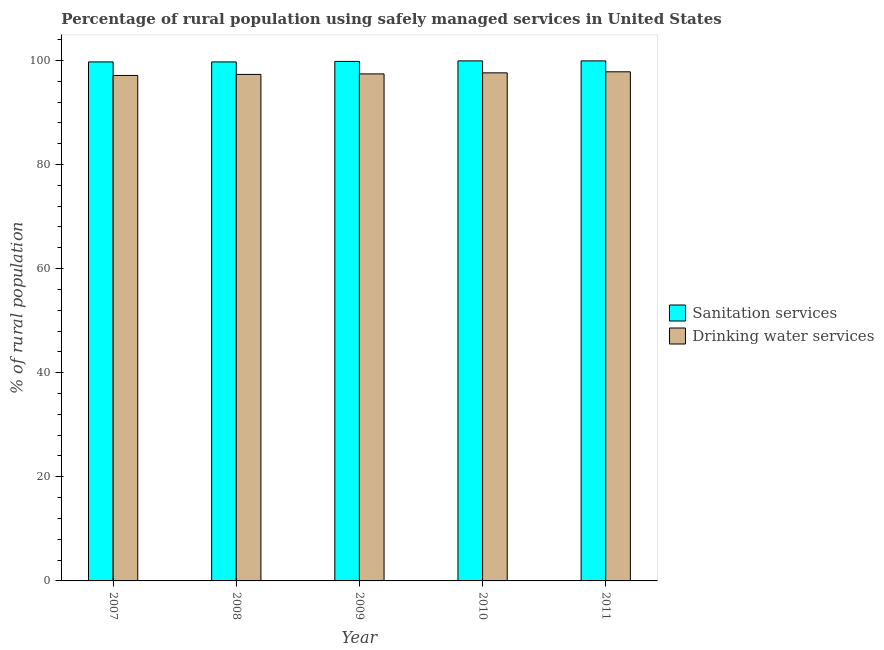How many groups of bars are there?
Make the answer very short. 5. Are the number of bars per tick equal to the number of legend labels?
Provide a succinct answer. Yes. How many bars are there on the 2nd tick from the left?
Make the answer very short. 2. How many bars are there on the 5th tick from the right?
Your answer should be compact. 2. What is the percentage of rural population who used sanitation services in 2011?
Make the answer very short. 99.9. Across all years, what is the maximum percentage of rural population who used drinking water services?
Offer a terse response. 97.8. Across all years, what is the minimum percentage of rural population who used drinking water services?
Your answer should be compact. 97.1. In which year was the percentage of rural population who used sanitation services maximum?
Offer a terse response. 2010. In which year was the percentage of rural population who used sanitation services minimum?
Your answer should be compact. 2007. What is the total percentage of rural population who used sanitation services in the graph?
Your response must be concise. 499. What is the difference between the percentage of rural population who used sanitation services in 2007 and that in 2008?
Keep it short and to the point. 0. What is the difference between the percentage of rural population who used sanitation services in 2008 and the percentage of rural population who used drinking water services in 2009?
Provide a short and direct response. -0.1. What is the average percentage of rural population who used drinking water services per year?
Offer a very short reply. 97.44. In the year 2011, what is the difference between the percentage of rural population who used drinking water services and percentage of rural population who used sanitation services?
Offer a very short reply. 0. What is the ratio of the percentage of rural population who used drinking water services in 2009 to that in 2010?
Your answer should be compact. 1. Is the percentage of rural population who used drinking water services in 2007 less than that in 2009?
Keep it short and to the point. Yes. Is the difference between the percentage of rural population who used drinking water services in 2007 and 2010 greater than the difference between the percentage of rural population who used sanitation services in 2007 and 2010?
Offer a terse response. No. What is the difference between the highest and the second highest percentage of rural population who used drinking water services?
Give a very brief answer. 0.2. What is the difference between the highest and the lowest percentage of rural population who used drinking water services?
Give a very brief answer. 0.7. What does the 2nd bar from the left in 2007 represents?
Provide a short and direct response. Drinking water services. What does the 2nd bar from the right in 2011 represents?
Your answer should be compact. Sanitation services. Are all the bars in the graph horizontal?
Your response must be concise. No. What is the difference between two consecutive major ticks on the Y-axis?
Your answer should be very brief. 20. Does the graph contain grids?
Offer a terse response. No. What is the title of the graph?
Give a very brief answer. Percentage of rural population using safely managed services in United States. What is the label or title of the X-axis?
Make the answer very short. Year. What is the label or title of the Y-axis?
Give a very brief answer. % of rural population. What is the % of rural population in Sanitation services in 2007?
Offer a very short reply. 99.7. What is the % of rural population in Drinking water services in 2007?
Offer a very short reply. 97.1. What is the % of rural population of Sanitation services in 2008?
Make the answer very short. 99.7. What is the % of rural population in Drinking water services in 2008?
Your answer should be compact. 97.3. What is the % of rural population of Sanitation services in 2009?
Keep it short and to the point. 99.8. What is the % of rural population of Drinking water services in 2009?
Provide a succinct answer. 97.4. What is the % of rural population in Sanitation services in 2010?
Provide a short and direct response. 99.9. What is the % of rural population of Drinking water services in 2010?
Keep it short and to the point. 97.6. What is the % of rural population of Sanitation services in 2011?
Keep it short and to the point. 99.9. What is the % of rural population in Drinking water services in 2011?
Your answer should be very brief. 97.8. Across all years, what is the maximum % of rural population in Sanitation services?
Your answer should be compact. 99.9. Across all years, what is the maximum % of rural population of Drinking water services?
Your response must be concise. 97.8. Across all years, what is the minimum % of rural population in Sanitation services?
Make the answer very short. 99.7. Across all years, what is the minimum % of rural population in Drinking water services?
Your answer should be very brief. 97.1. What is the total % of rural population of Sanitation services in the graph?
Offer a very short reply. 499. What is the total % of rural population in Drinking water services in the graph?
Offer a very short reply. 487.2. What is the difference between the % of rural population in Drinking water services in 2007 and that in 2008?
Ensure brevity in your answer.  -0.2. What is the difference between the % of rural population of Sanitation services in 2007 and that in 2009?
Provide a succinct answer. -0.1. What is the difference between the % of rural population in Drinking water services in 2007 and that in 2009?
Your answer should be very brief. -0.3. What is the difference between the % of rural population in Drinking water services in 2007 and that in 2011?
Provide a succinct answer. -0.7. What is the difference between the % of rural population in Drinking water services in 2008 and that in 2009?
Your response must be concise. -0.1. What is the difference between the % of rural population of Sanitation services in 2008 and that in 2011?
Your answer should be compact. -0.2. What is the difference between the % of rural population in Sanitation services in 2009 and that in 2011?
Your answer should be compact. -0.1. What is the difference between the % of rural population in Drinking water services in 2009 and that in 2011?
Offer a very short reply. -0.4. What is the difference between the % of rural population in Sanitation services in 2007 and the % of rural population in Drinking water services in 2008?
Your response must be concise. 2.4. What is the difference between the % of rural population in Sanitation services in 2007 and the % of rural population in Drinking water services in 2009?
Your answer should be compact. 2.3. What is the difference between the % of rural population in Sanitation services in 2007 and the % of rural population in Drinking water services in 2010?
Provide a short and direct response. 2.1. What is the difference between the % of rural population of Sanitation services in 2008 and the % of rural population of Drinking water services in 2009?
Your answer should be compact. 2.3. What is the difference between the % of rural population of Sanitation services in 2009 and the % of rural population of Drinking water services in 2011?
Give a very brief answer. 2. What is the average % of rural population of Sanitation services per year?
Your answer should be compact. 99.8. What is the average % of rural population of Drinking water services per year?
Offer a terse response. 97.44. In the year 2010, what is the difference between the % of rural population in Sanitation services and % of rural population in Drinking water services?
Keep it short and to the point. 2.3. In the year 2011, what is the difference between the % of rural population of Sanitation services and % of rural population of Drinking water services?
Provide a short and direct response. 2.1. What is the ratio of the % of rural population of Sanitation services in 2007 to that in 2008?
Offer a terse response. 1. What is the ratio of the % of rural population of Drinking water services in 2007 to that in 2008?
Provide a short and direct response. 1. What is the ratio of the % of rural population of Drinking water services in 2007 to that in 2009?
Give a very brief answer. 1. What is the ratio of the % of rural population in Sanitation services in 2007 to that in 2010?
Offer a very short reply. 1. What is the ratio of the % of rural population of Drinking water services in 2008 to that in 2010?
Ensure brevity in your answer.  1. What is the ratio of the % of rural population in Sanitation services in 2009 to that in 2010?
Offer a very short reply. 1. What is the ratio of the % of rural population in Sanitation services in 2009 to that in 2011?
Provide a succinct answer. 1. What is the ratio of the % of rural population in Drinking water services in 2009 to that in 2011?
Give a very brief answer. 1. What is the difference between the highest and the second highest % of rural population in Sanitation services?
Make the answer very short. 0. What is the difference between the highest and the second highest % of rural population in Drinking water services?
Provide a short and direct response. 0.2. 